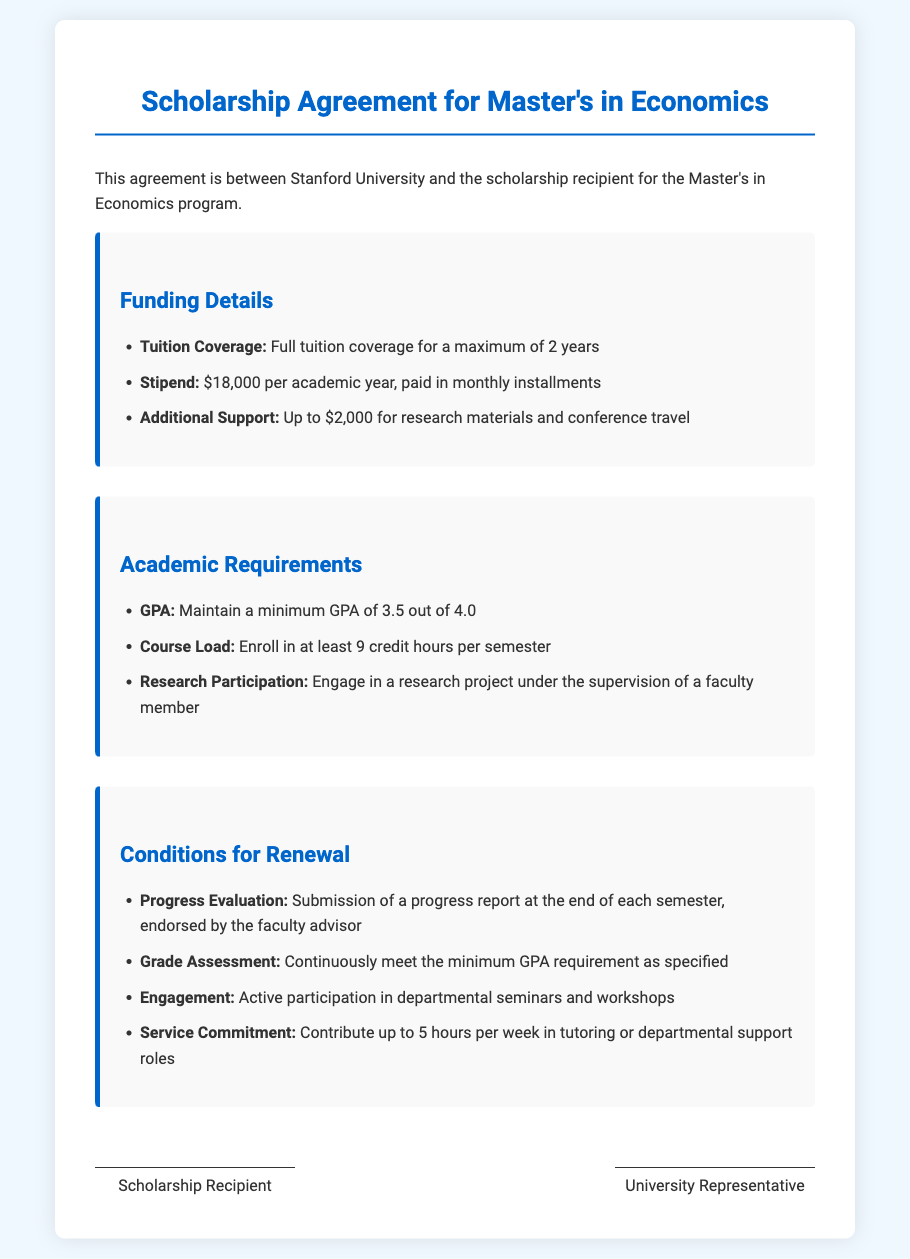What is the tuition coverage? The tuition coverage is detailed in the Funding Details section of the document, which states it is full tuition coverage for a maximum of 2 years.
Answer: Full tuition coverage for a maximum of 2 years What is the stipend amount per academic year? The stipend amount is listed under Funding Details, clearly stating that it is $18,000 per academic year.
Answer: $18,000 What is the minimum GPA requirement? The minimum GPA requirement is mentioned in the Academic Requirements section, which specifies maintaining a GPA of 3.5 out of 4.0.
Answer: 3.5 How many credit hours must be enrolled in per semester? The course load requirement is outlined in the Academic Requirements section, which states that at least 9 credit hours per semester must be enrolled in.
Answer: At least 9 credit hours What is the maximum amount for additional support? The additional support amount is detailed under Funding Details, indicating that it can be up to $2,000 for research materials and conference travel.
Answer: Up to $2,000 What is required for renewal evaluation? The renewal process includes a submission of a progress report, which is mentioned under Conditions for Renewal, and must be endorsed by the faculty advisor.
Answer: Submission of a progress report How many hours per week must be contributed for service? The service commitment outlined in the Conditions for Renewal specifies that the scholarship recipient must contribute up to 5 hours per week in tutoring or departmental support.
Answer: Up to 5 hours What type of participation is required in departmental activities? The engagement requirement in the Conditions for Renewal mandates active participation in departmental seminars and workshops.
Answer: Active participation in departmental seminars and workshops 